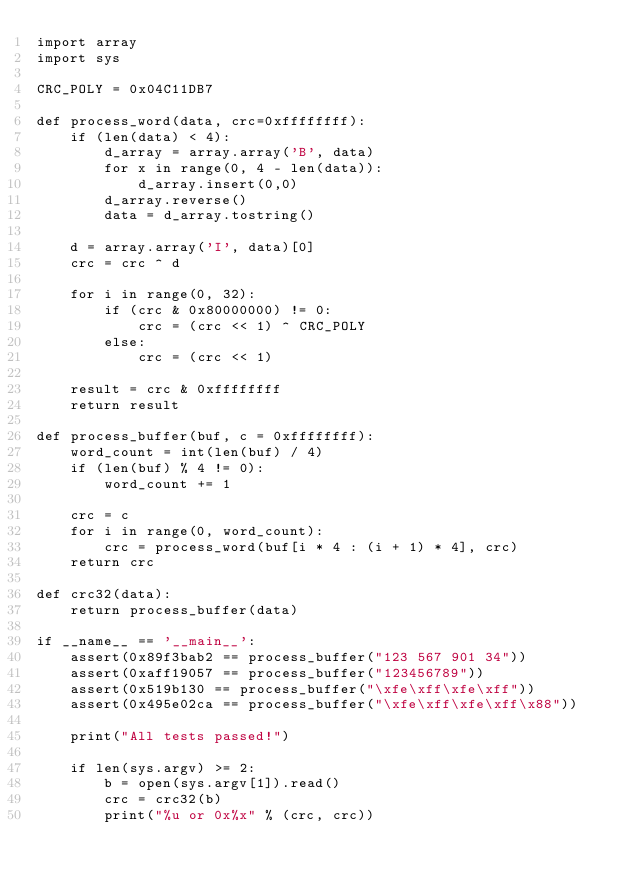Convert code to text. <code><loc_0><loc_0><loc_500><loc_500><_Python_>import array
import sys

CRC_POLY = 0x04C11DB7

def process_word(data, crc=0xffffffff):
    if (len(data) < 4):
        d_array = array.array('B', data)
        for x in range(0, 4 - len(data)):
            d_array.insert(0,0)
        d_array.reverse()
        data = d_array.tostring()

    d = array.array('I', data)[0]
    crc = crc ^ d

    for i in range(0, 32):
        if (crc & 0x80000000) != 0:
            crc = (crc << 1) ^ CRC_POLY
        else:
            crc = (crc << 1)

    result = crc & 0xffffffff
    return result

def process_buffer(buf, c = 0xffffffff):
    word_count = int(len(buf) / 4)
    if (len(buf) % 4 != 0):
        word_count += 1

    crc = c
    for i in range(0, word_count):
        crc = process_word(buf[i * 4 : (i + 1) * 4], crc)
    return crc

def crc32(data):
    return process_buffer(data)

if __name__ == '__main__':
    assert(0x89f3bab2 == process_buffer("123 567 901 34"))
    assert(0xaff19057 == process_buffer("123456789"))
    assert(0x519b130 == process_buffer("\xfe\xff\xfe\xff"))
    assert(0x495e02ca == process_buffer("\xfe\xff\xfe\xff\x88"))

    print("All tests passed!")

    if len(sys.argv) >= 2:
        b = open(sys.argv[1]).read()
        crc = crc32(b)
        print("%u or 0x%x" % (crc, crc))
</code> 